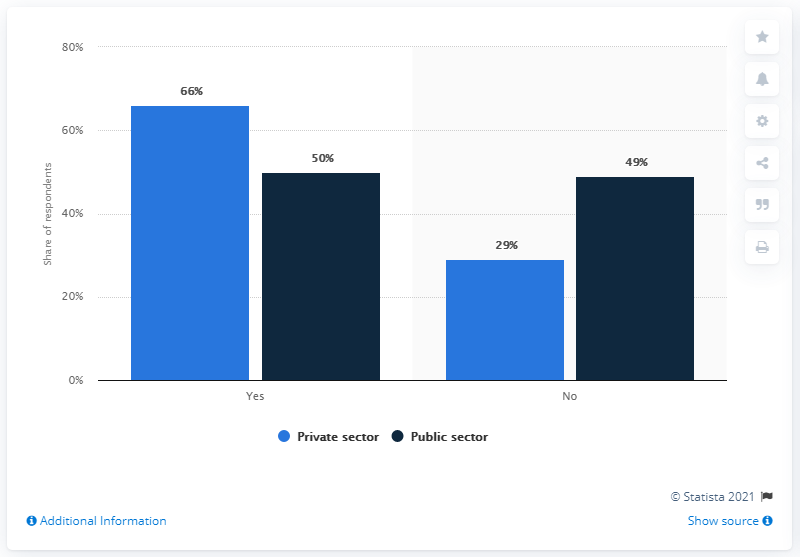Specify some key components in this picture. The workers in the private sector have a broader range of opinions between voting "Yes" and "No" compared to workers in other sectors. The navy blue bars in the chart represent the public sector. 